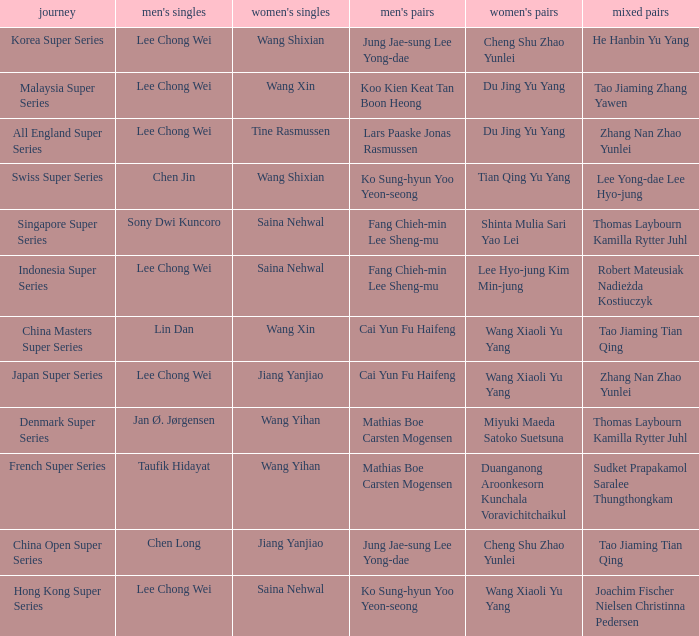Who is the women's doubles when the mixed doubles are sudket prapakamol saralee thungthongkam? Duanganong Aroonkesorn Kunchala Voravichitchaikul. 